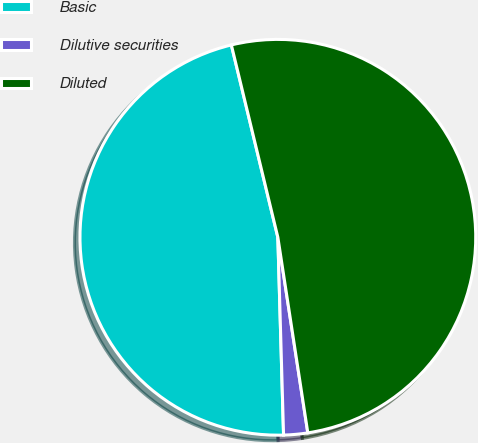<chart> <loc_0><loc_0><loc_500><loc_500><pie_chart><fcel>Basic<fcel>Dilutive securities<fcel>Diluted<nl><fcel>46.68%<fcel>1.96%<fcel>51.35%<nl></chart> 